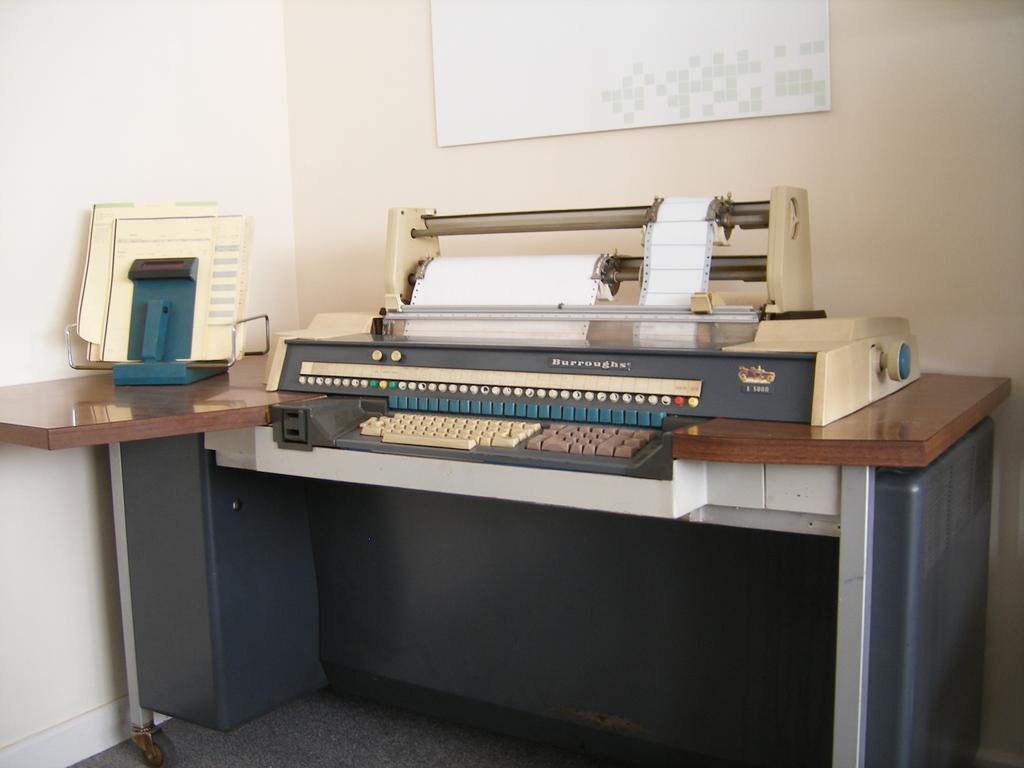How would you summarize this image in a sentence or two? This picture is consists of a typewriter, which is placed on the table at the center of the image. 